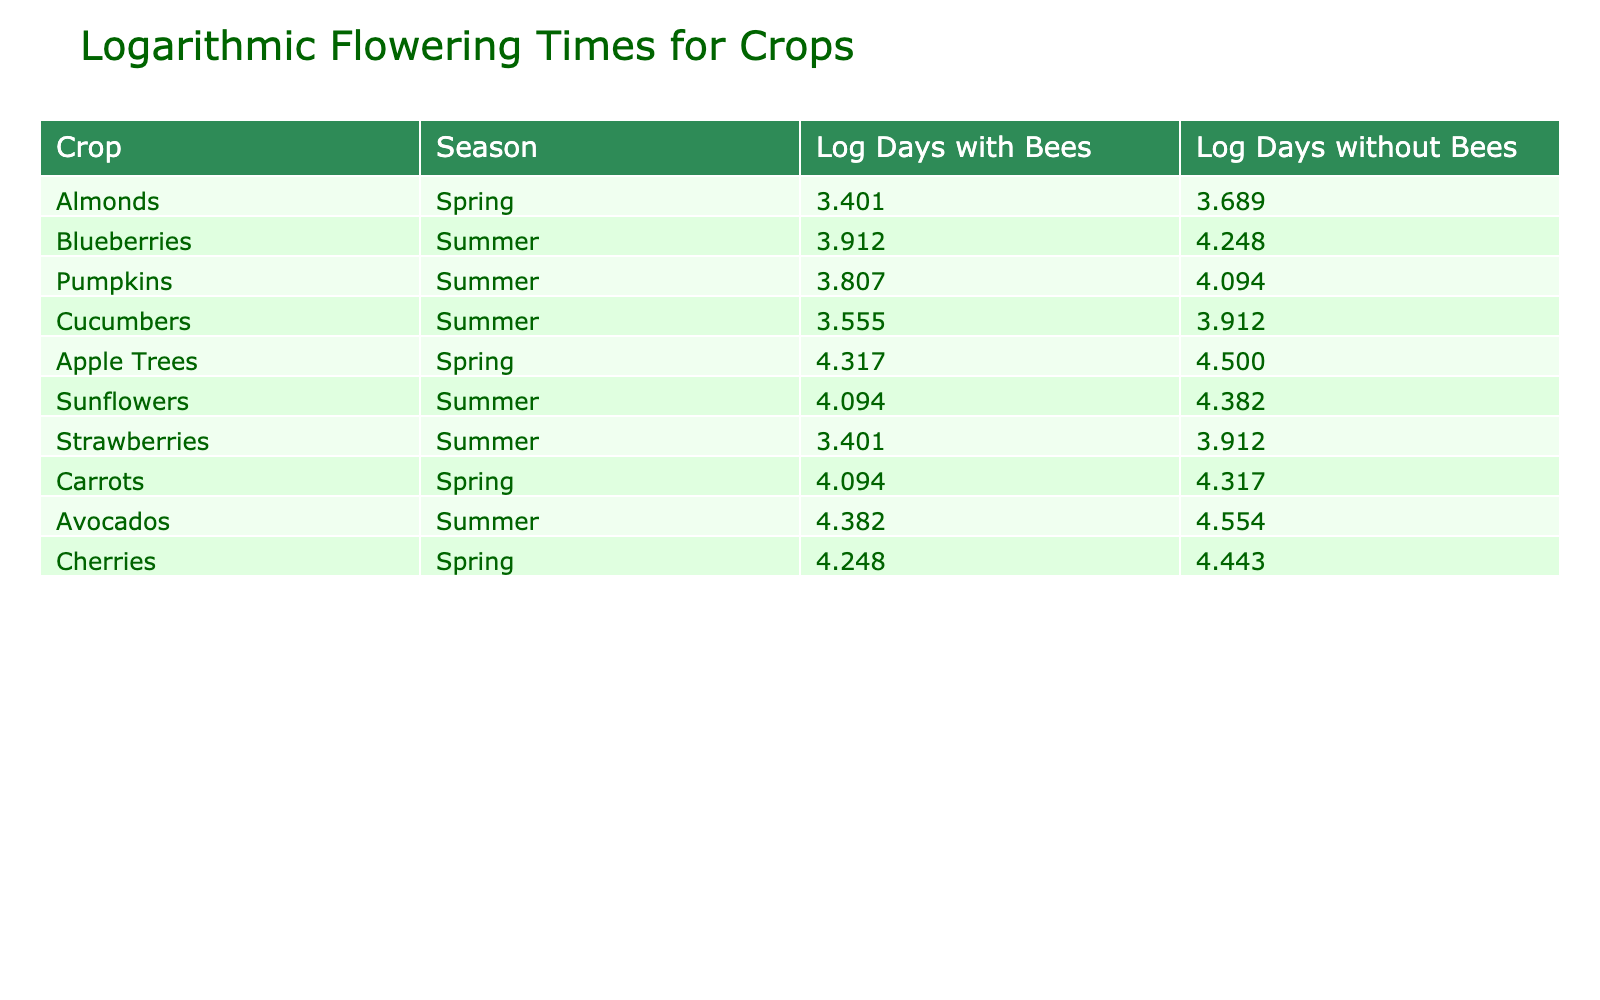What are the logarithmic flowering days for strawberries with bees? From the table, locate the row corresponding to strawberries. The value for "Days to Flowering with Bees" is 30. The logarithmic value is calculated as log(30) which equals approximately 3.401.
Answer: 3.401 How many days do apple trees take to flower without bees? The table lists the "Days to Flowering without Bees" for apple trees as 90 days.
Answer: 90 What is the difference in logarithmic flowering days for cucumbers with and without bees? For cucumbers, the logarithmic value with bees is log(35) which is approximately 3.555, and for without bees, it is log(50) which is approximately 3.912. The difference is 3.912 - 3.555 = 0.357.
Answer: 0.357 Do cherries take fewer days to flower with bees compared to without bees? By examining the table, cherries take 70 days with bees and 85 days without bees. Since 70 is less than 85, the statement is true.
Answer: Yes What is the average of the logarithmic flowering days with bees across all crops listed? First, calculate the logarithmic values for all crops with bees: Almonds (3.401), Apples (4.317), Cherries (4.248), Cucumbers (3.555), Pumpkins (3.583), Strawberries (3.401), Sunflowers (4.094), Blueberries (3.912), Carrots (4.094), and Avocados (4.382). The sum is approximately 38.909. There are 10 crops, thus the average is 38.909 / 10 = 3.891.
Answer: 3.891 Is the log value for days to flowering with bees greater than the log value for days to flowering without bees for all crops? Comparing the log values from the table, in all cases the values with bees are less than the values without bees. Therefore, the statement is false.
Answer: No 